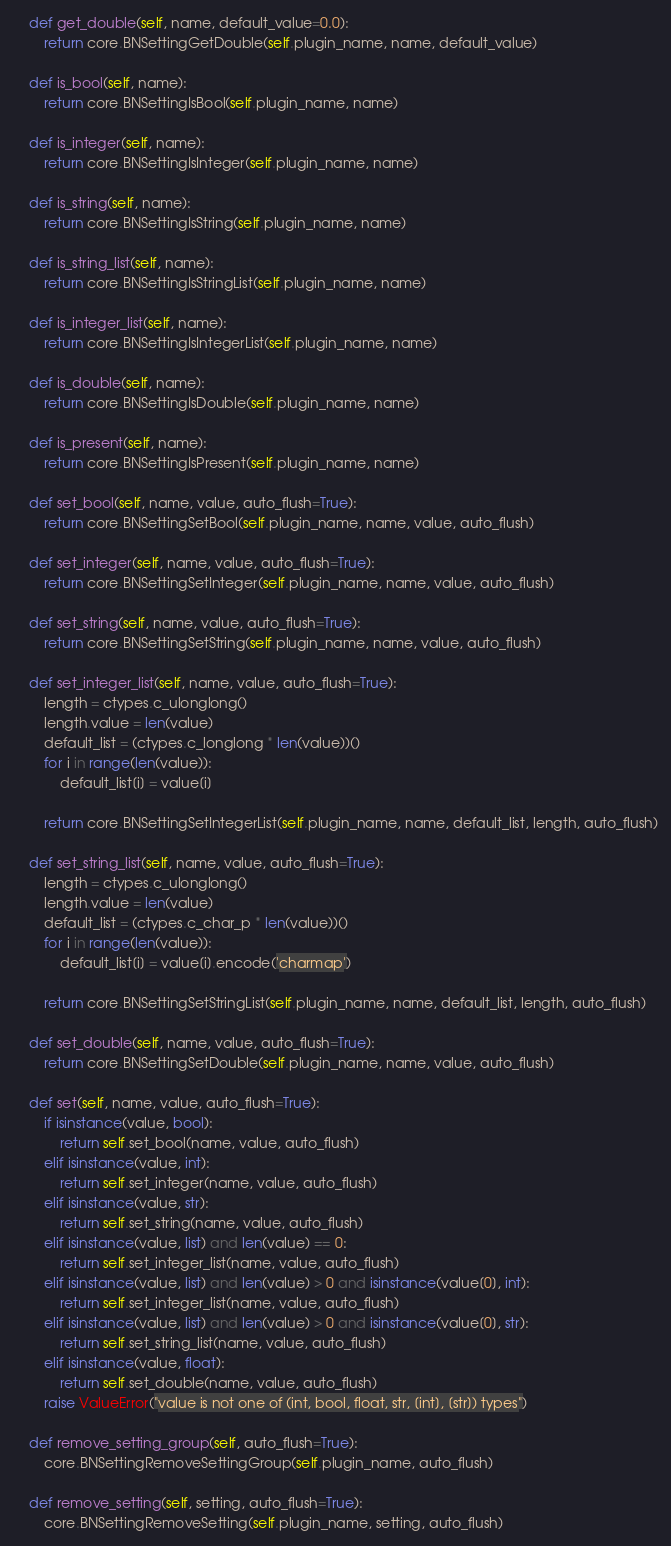Convert code to text. <code><loc_0><loc_0><loc_500><loc_500><_Python_>
	def get_double(self, name, default_value=0.0):
		return core.BNSettingGetDouble(self.plugin_name, name, default_value)

	def is_bool(self, name):
		return core.BNSettingIsBool(self.plugin_name, name)

	def is_integer(self, name):
		return core.BNSettingIsInteger(self.plugin_name, name)

	def is_string(self, name):
		return core.BNSettingIsString(self.plugin_name, name)

	def is_string_list(self, name):
		return core.BNSettingIsStringList(self.plugin_name, name)

	def is_integer_list(self, name):
		return core.BNSettingIsIntegerList(self.plugin_name, name)

	def is_double(self, name):
		return core.BNSettingIsDouble(self.plugin_name, name)

	def is_present(self, name):
		return core.BNSettingIsPresent(self.plugin_name, name)

	def set_bool(self, name, value, auto_flush=True):
		return core.BNSettingSetBool(self.plugin_name, name, value, auto_flush)

	def set_integer(self, name, value, auto_flush=True):
		return core.BNSettingSetInteger(self.plugin_name, name, value, auto_flush)

	def set_string(self, name, value, auto_flush=True):
		return core.BNSettingSetString(self.plugin_name, name, value, auto_flush)

	def set_integer_list(self, name, value, auto_flush=True):
		length = ctypes.c_ulonglong()
		length.value = len(value)
		default_list = (ctypes.c_longlong * len(value))()
		for i in range(len(value)):
			default_list[i] = value[i]

		return core.BNSettingSetIntegerList(self.plugin_name, name, default_list, length, auto_flush)

	def set_string_list(self, name, value, auto_flush=True):
		length = ctypes.c_ulonglong()
		length.value = len(value)
		default_list = (ctypes.c_char_p * len(value))()
		for i in range(len(value)):
			default_list[i] = value[i].encode('charmap')

		return core.BNSettingSetStringList(self.plugin_name, name, default_list, length, auto_flush)

	def set_double(self, name, value, auto_flush=True):
		return core.BNSettingSetDouble(self.plugin_name, name, value, auto_flush)

	def set(self, name, value, auto_flush=True):
		if isinstance(value, bool):
			return self.set_bool(name, value, auto_flush)
		elif isinstance(value, int):
			return self.set_integer(name, value, auto_flush)
		elif isinstance(value, str):
			return self.set_string(name, value, auto_flush)
		elif isinstance(value, list) and len(value) == 0:
			return self.set_integer_list(name, value, auto_flush)
		elif isinstance(value, list) and len(value) > 0 and isinstance(value[0], int):
			return self.set_integer_list(name, value, auto_flush)
		elif isinstance(value, list) and len(value) > 0 and isinstance(value[0], str):
			return self.set_string_list(name, value, auto_flush)
		elif isinstance(value, float):
			return self.set_double(name, value, auto_flush)
		raise ValueError("value is not one of (int, bool, float, str, [int], [str]) types")

	def remove_setting_group(self, auto_flush=True):
		core.BNSettingRemoveSettingGroup(self.plugin_name, auto_flush)

	def remove_setting(self, setting, auto_flush=True):
		core.BNSettingRemoveSetting(self.plugin_name, setting, auto_flush)</code> 